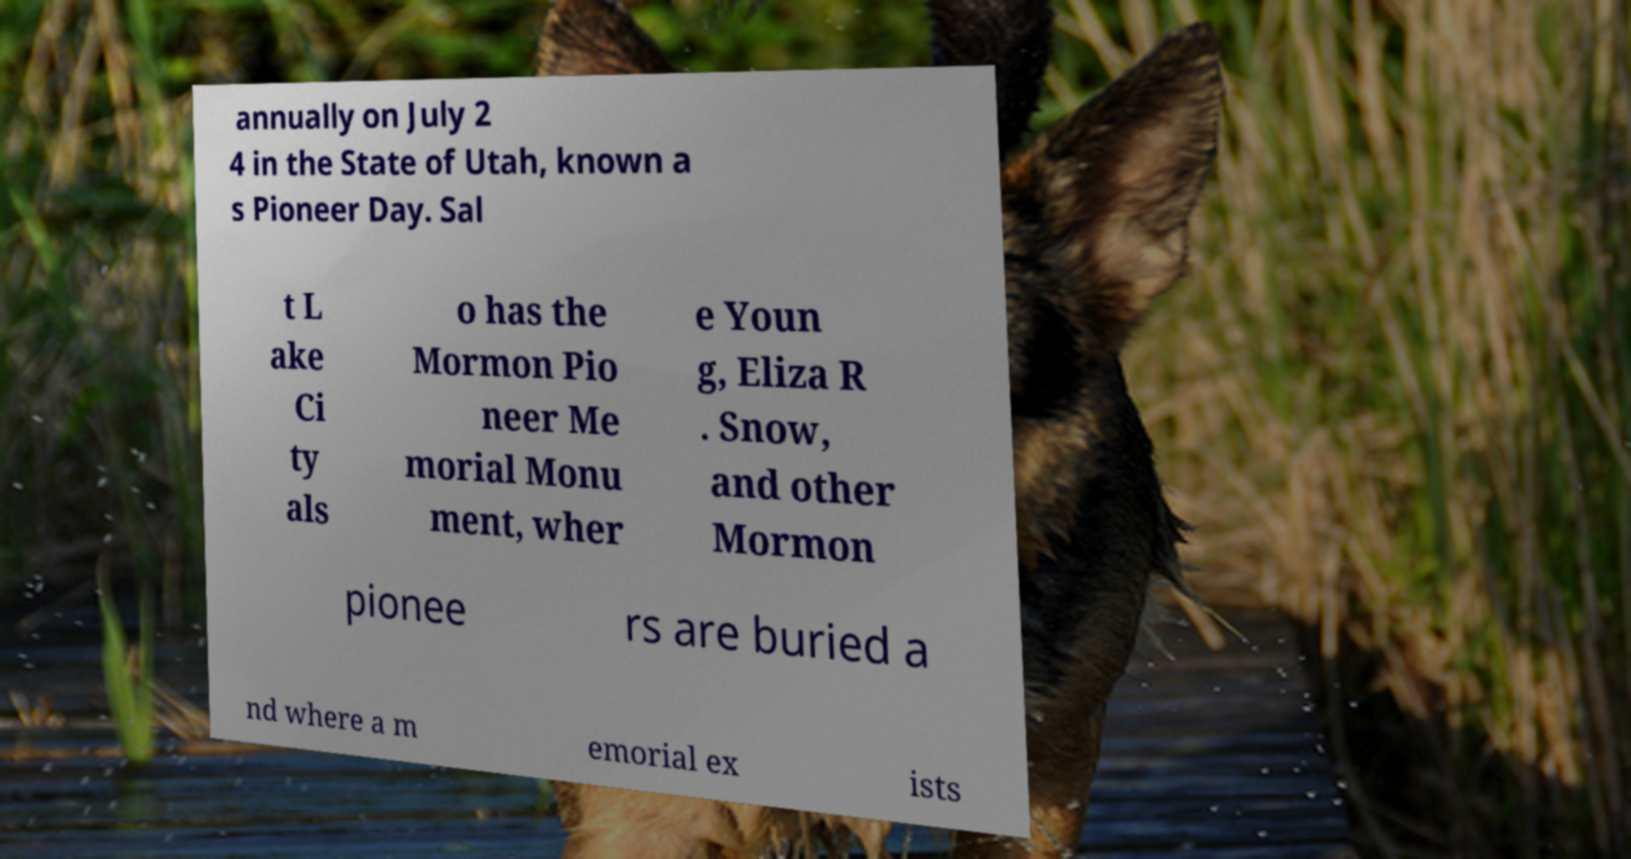I need the written content from this picture converted into text. Can you do that? annually on July 2 4 in the State of Utah, known a s Pioneer Day. Sal t L ake Ci ty als o has the Mormon Pio neer Me morial Monu ment, wher e Youn g, Eliza R . Snow, and other Mormon pionee rs are buried a nd where a m emorial ex ists 